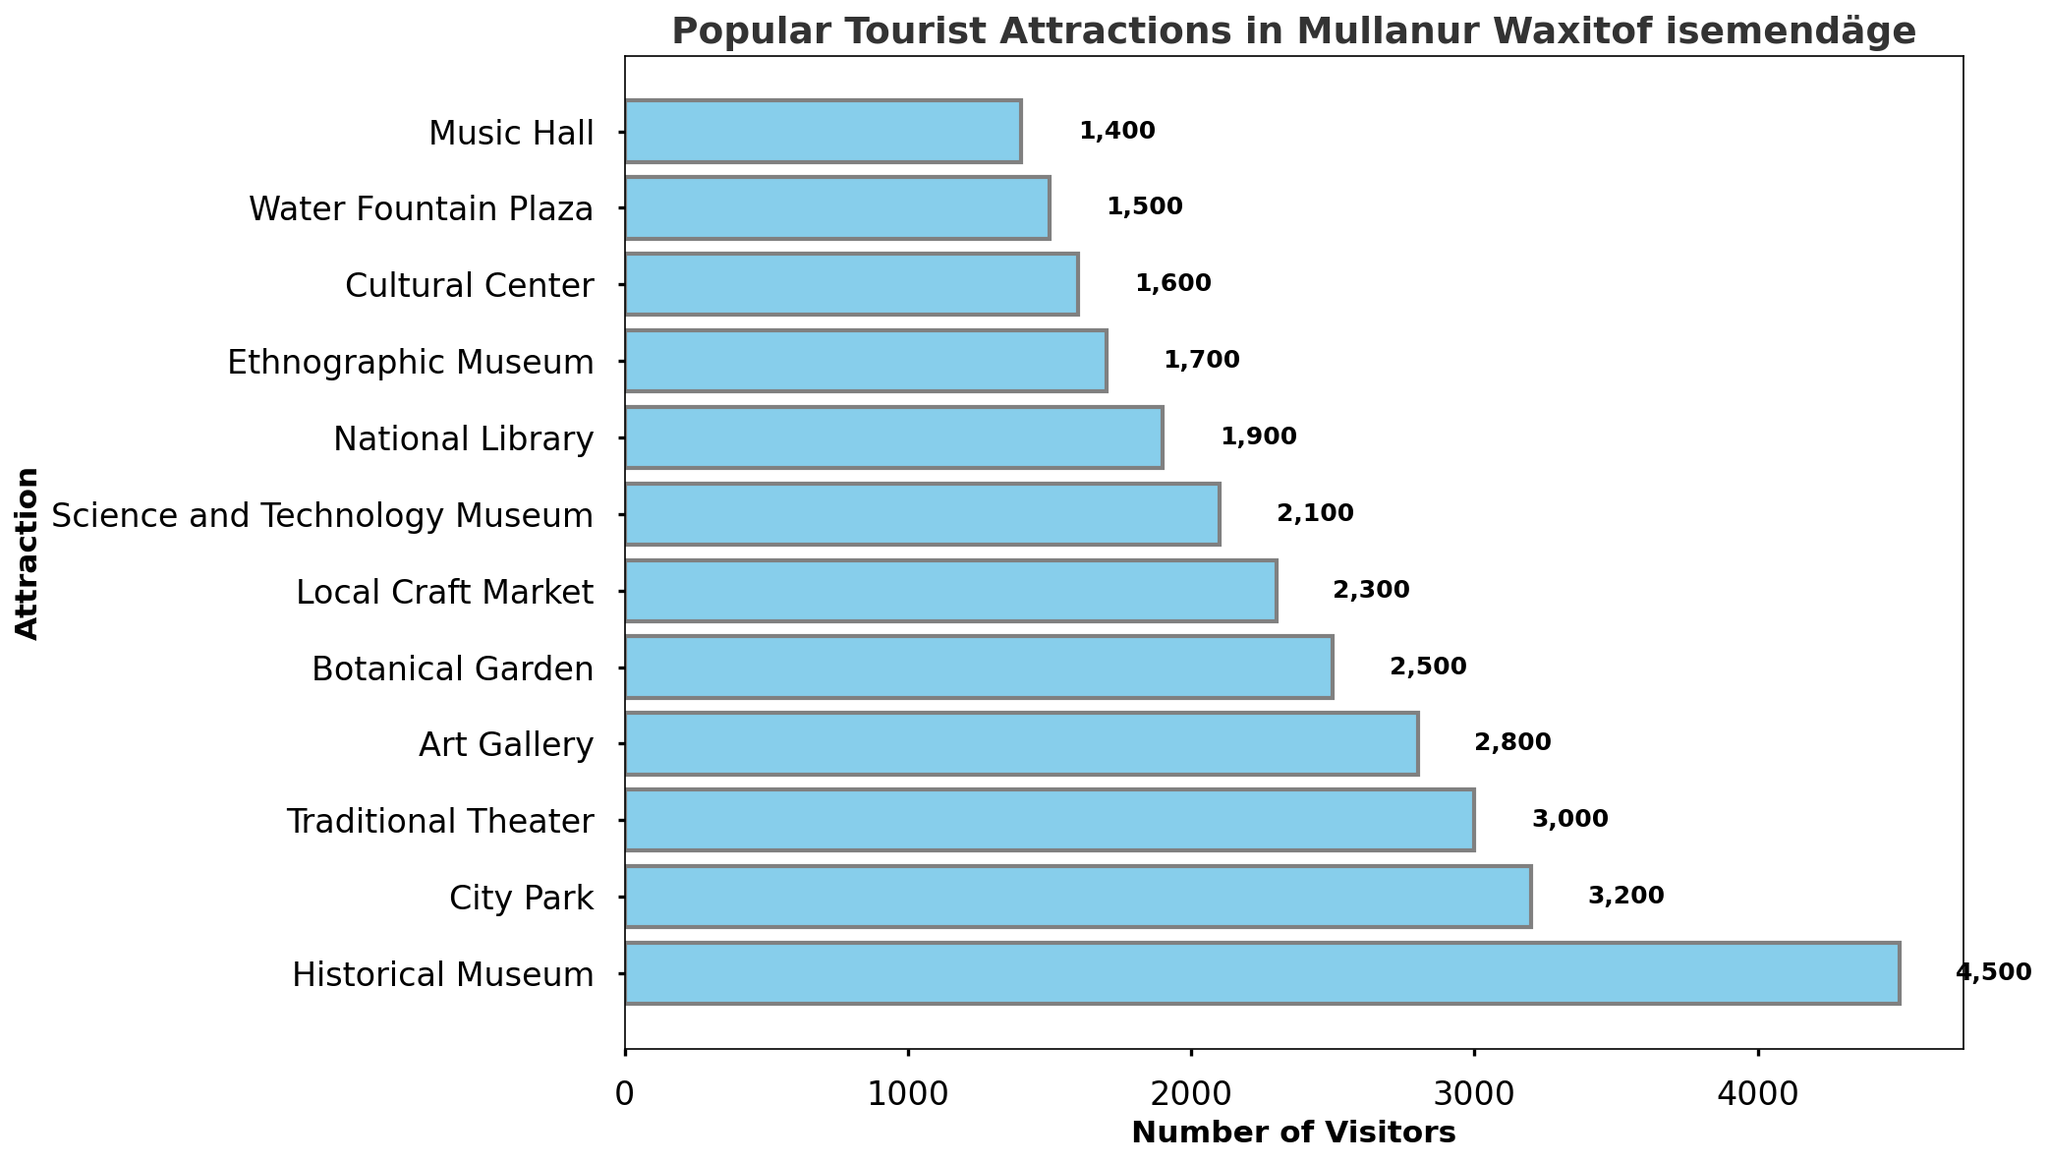What's the most popular tourist attraction in Mullanur Waxitof isemendäge? The bar chart shows the number of visitors for each attraction, with "Historical Museum" having the highest bar, indicating it's the most popular attraction.
Answer: Historical Museum Which tourist attraction has the fewest visitors? Looking at the bar lengths from the chart, the "Music Hall" has the shortest bar, indicating the fewest visitors.
Answer: Music Hall How many more visitors does the Historical Museum have compared to the City Park? The number of visitors for the Historical Museum is 4500, and for the City Park is 3200. Subtract 3200 from 4500 to get the difference. 4500 - 3200 = 1300
Answer: 1300 What is the average number of visitors across all attractions? Sum all visitors: 4500 + 3200 + 2800 + 1500 + 2300 + 1900 + 2500 + 1600 + 3000 + 2100 + 1400 + 1700 = 28600. There are 12 attractions. Average = 28600 / 12 = 2383.33
Answer: 2383.33 How does the number of visitors to the Science and Technology Museum compare to the National Library? The Science and Technology Museum has 2100 visitors, and the National Library has 1900 visitors. Comparing these numbers, 2100 is greater than 1900.
Answer: Science and Technology Museum has more visitors What is the sum of visitors to the three least popular attractions? The three least popular attractions are "Music Hall" (1400 visitors), "Water Fountain Plaza" (1500 visitors), and "Cultural Center" (1600 visitors). Sum: 1400 + 1500 + 1600 = 4500
Answer: 4500 What is the median number of visitors among the attractions? Arrange the visitor numbers in ascending order: 1400, 1500, 1600, 1700, 1900, 2100, 2300, 2500, 2800, 3000, 3200, 4500. The median is the average of the 6th and 7th values: (2100 + 2300) / 2 = 2200
Answer: 2200 Which attraction has slightly fewer visitors: Botanical Garden or Traditional Theater? The Botanical Garden has 2500 visitors, and the Traditional Theater has 3000 visitors. 2500 is less than 3000.
Answer: Botanical Garden If the Ethnographic Museum increased its visitors by 800, which attractions would it surpass in visitor count? The Ethnographic Museum has 1700 visitors. Increasing by 800 gives 1700 + 800 = 2500. Attractions it would surpass: "National Library" (1900), "Science and Technology Museum" (2100), and "Botanical Garden" (2500). However, it would tie with the Botanical Garden.
Answer: National Library, Science and Technology Museum, Botanical Garden (tie) Which attractions have between 2000 and 3000 visitors? From the chart, the attractions in this range are "Art Gallery" (2800), "Local Craft Market" (2300), "Botanical Garden" (2500), Traditional Theater (3000), and "Science and Technology Museum" (2100).
Answer: Art Gallery, Local Craft Market, Botanical Garden, Traditional Theater, Science and Technology Museum 